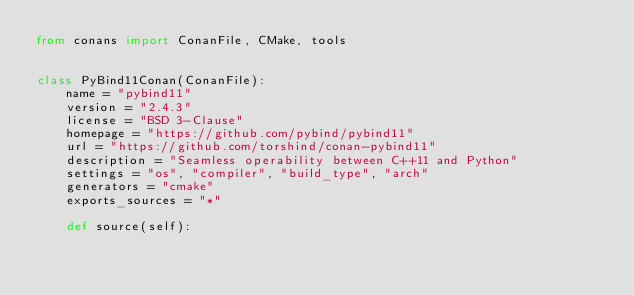Convert code to text. <code><loc_0><loc_0><loc_500><loc_500><_Python_>from conans import ConanFile, CMake, tools


class PyBind11Conan(ConanFile):
    name = "pybind11"
    version = "2.4.3"
    license = "BSD 3-Clause"
    homepage = "https://github.com/pybind/pybind11"
    url = "https://github.com/torshind/conan-pybind11"
    description = "Seamless operability between C++11 and Python"
    settings = "os", "compiler", "build_type", "arch"
    generators = "cmake"
    exports_sources = "*"

    def source(self):</code> 